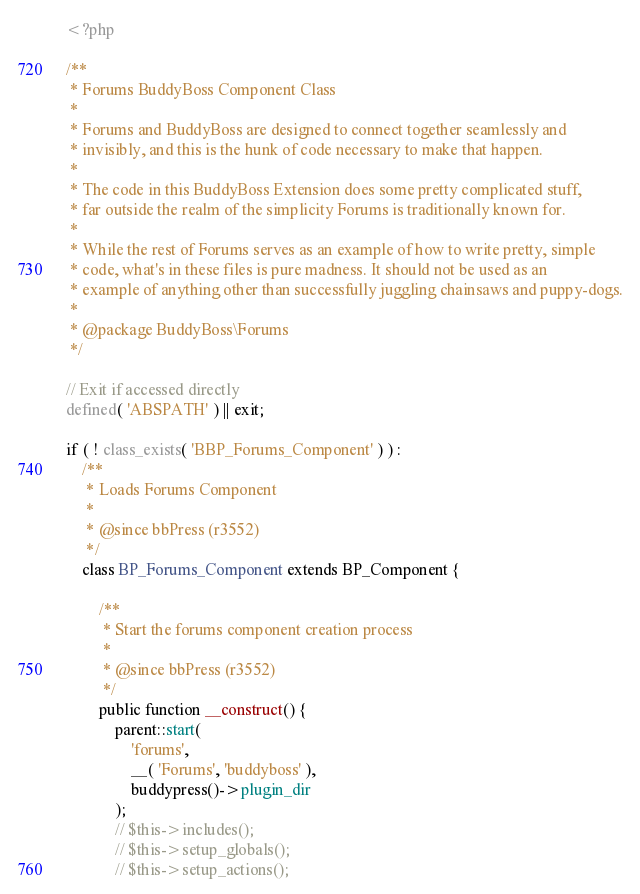Convert code to text. <code><loc_0><loc_0><loc_500><loc_500><_PHP_><?php

/**
 * Forums BuddyBoss Component Class
 *
 * Forums and BuddyBoss are designed to connect together seamlessly and
 * invisibly, and this is the hunk of code necessary to make that happen.
 *
 * The code in this BuddyBoss Extension does some pretty complicated stuff,
 * far outside the realm of the simplicity Forums is traditionally known for.
 *
 * While the rest of Forums serves as an example of how to write pretty, simple
 * code, what's in these files is pure madness. It should not be used as an
 * example of anything other than successfully juggling chainsaws and puppy-dogs.
 *
 * @package BuddyBoss\Forums
 */

// Exit if accessed directly
defined( 'ABSPATH' ) || exit;

if ( ! class_exists( 'BBP_Forums_Component' ) ) :
	/**
	 * Loads Forums Component
	 *
	 * @since bbPress (r3552)
	 */
	class BP_Forums_Component extends BP_Component {

		/**
		 * Start the forums component creation process
		 *
		 * @since bbPress (r3552)
		 */
		public function __construct() {
			parent::start(
				'forums',
				__( 'Forums', 'buddyboss' ),
				buddypress()->plugin_dir
			);
			// $this->includes();
			// $this->setup_globals();
			// $this->setup_actions();</code> 